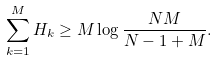Convert formula to latex. <formula><loc_0><loc_0><loc_500><loc_500>\sum _ { k = 1 } ^ { M } H _ { k } \geq M \log \frac { N M } { N - 1 + M } .</formula> 